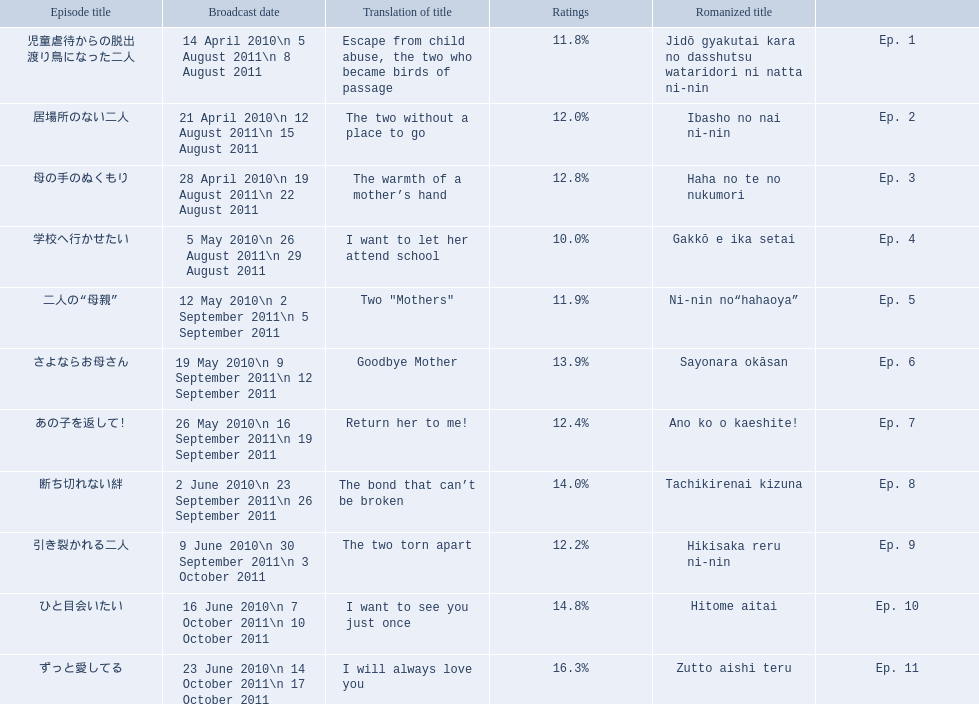What were the episode titles of mother? 児童虐待からの脱出 渡り鳥になった二人, 居場所のない二人, 母の手のぬくもり, 学校へ行かせたい, 二人の“母親”, さよならお母さん, あの子を返して!, 断ち切れない絆, 引き裂かれる二人, ひと目会いたい, ずっと愛してる. Which of these episodes had the highest ratings? ずっと愛してる. 